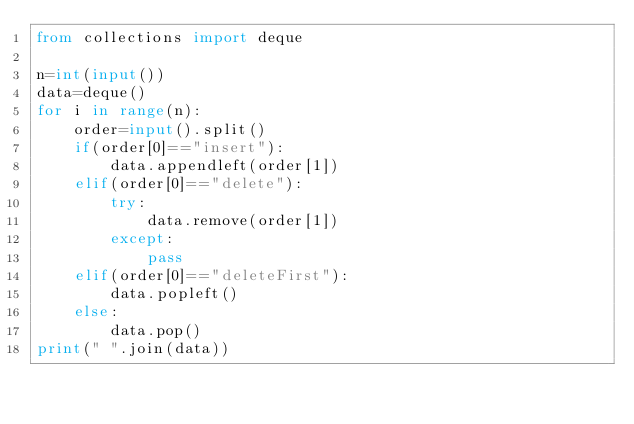Convert code to text. <code><loc_0><loc_0><loc_500><loc_500><_Python_>from collections import deque

n=int(input())
data=deque()
for i in range(n):
    order=input().split()
    if(order[0]=="insert"):
        data.appendleft(order[1])
    elif(order[0]=="delete"):
        try:
            data.remove(order[1])
        except:
            pass
    elif(order[0]=="deleteFirst"):
        data.popleft()
    else:
        data.pop()
print(" ".join(data))
</code> 